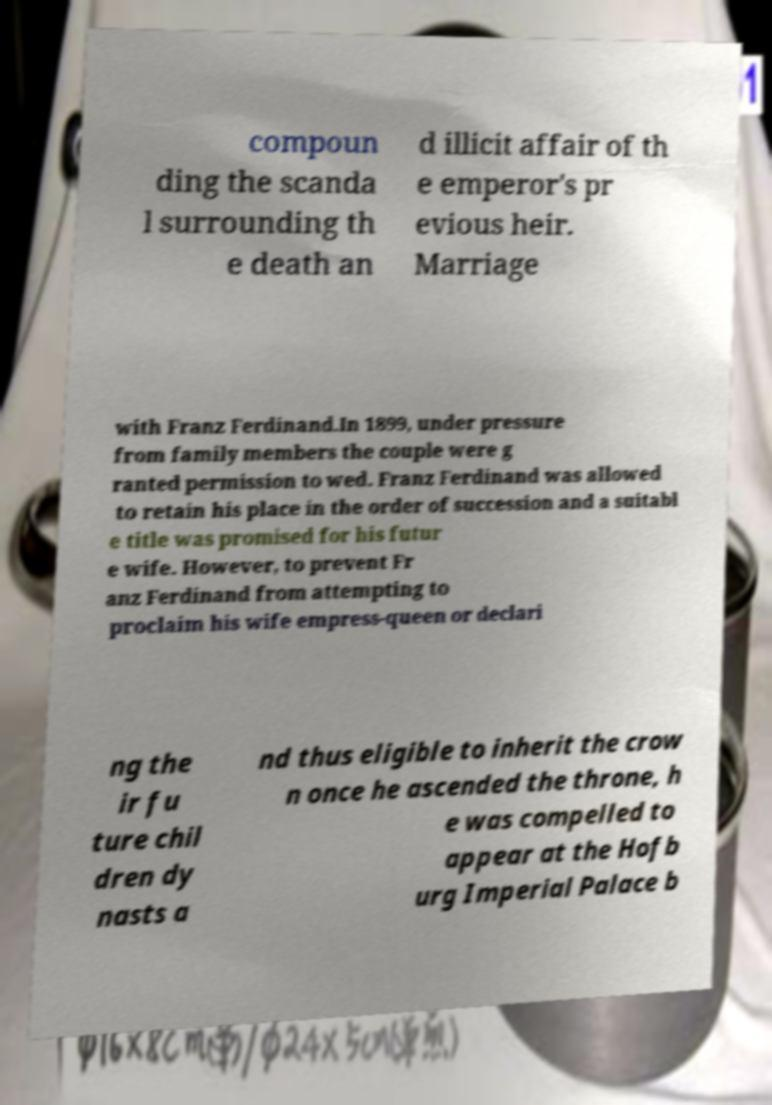Can you read and provide the text displayed in the image?This photo seems to have some interesting text. Can you extract and type it out for me? compoun ding the scanda l surrounding th e death an d illicit affair of th e emperor's pr evious heir. Marriage with Franz Ferdinand.In 1899, under pressure from family members the couple were g ranted permission to wed. Franz Ferdinand was allowed to retain his place in the order of succession and a suitabl e title was promised for his futur e wife. However, to prevent Fr anz Ferdinand from attempting to proclaim his wife empress-queen or declari ng the ir fu ture chil dren dy nasts a nd thus eligible to inherit the crow n once he ascended the throne, h e was compelled to appear at the Hofb urg Imperial Palace b 